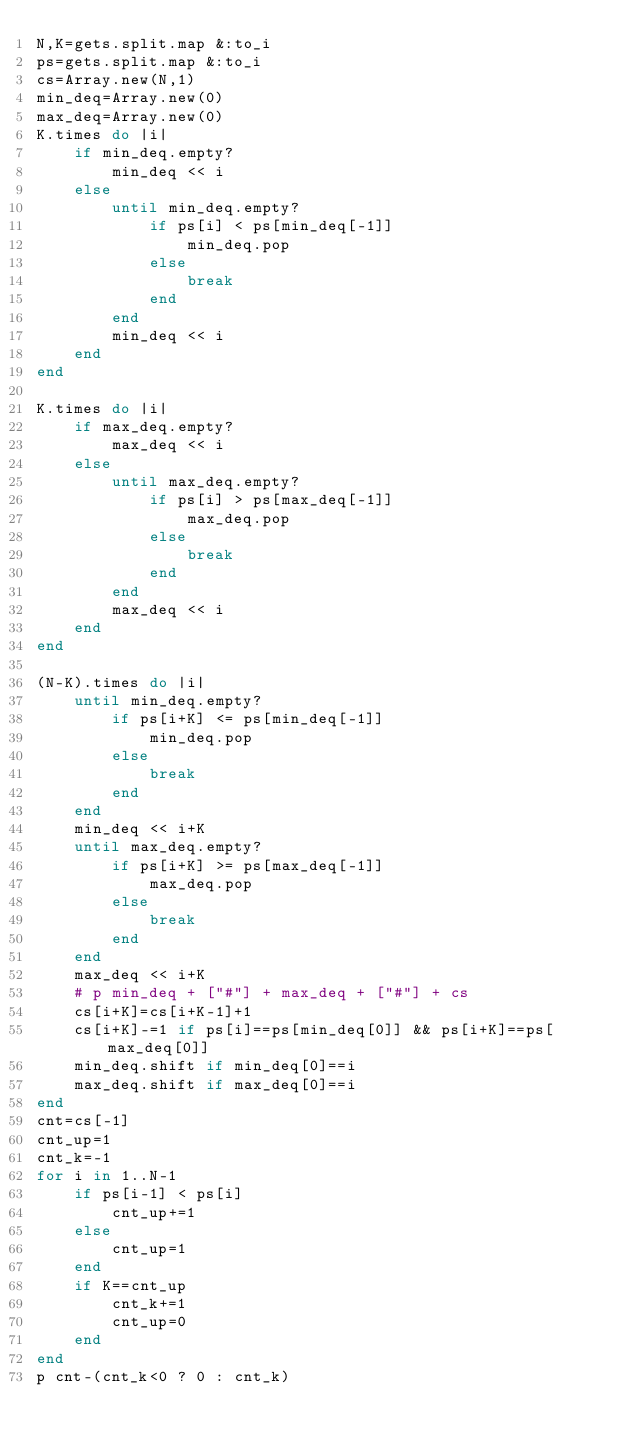Convert code to text. <code><loc_0><loc_0><loc_500><loc_500><_Ruby_>N,K=gets.split.map &:to_i
ps=gets.split.map &:to_i
cs=Array.new(N,1)
min_deq=Array.new(0)
max_deq=Array.new(0)
K.times do |i|
    if min_deq.empty?
        min_deq << i
    else
        until min_deq.empty?
            if ps[i] < ps[min_deq[-1]]
                min_deq.pop
            else
                break
            end
        end
        min_deq << i
    end
end

K.times do |i|
    if max_deq.empty?
        max_deq << i
    else
        until max_deq.empty?
            if ps[i] > ps[max_deq[-1]]
                max_deq.pop
            else
                break
            end
        end
        max_deq << i
    end
end

(N-K).times do |i|
    until min_deq.empty?
        if ps[i+K] <= ps[min_deq[-1]]
            min_deq.pop
        else
            break
        end
    end
    min_deq << i+K
    until max_deq.empty?
        if ps[i+K] >= ps[max_deq[-1]]
            max_deq.pop
        else
            break
        end
    end
    max_deq << i+K
    # p min_deq + ["#"] + max_deq + ["#"] + cs
    cs[i+K]=cs[i+K-1]+1
    cs[i+K]-=1 if ps[i]==ps[min_deq[0]] && ps[i+K]==ps[max_deq[0]]
    min_deq.shift if min_deq[0]==i
    max_deq.shift if max_deq[0]==i
end
cnt=cs[-1]
cnt_up=1
cnt_k=-1
for i in 1..N-1
    if ps[i-1] < ps[i]
        cnt_up+=1
    else
        cnt_up=1
    end
    if K==cnt_up
        cnt_k+=1
        cnt_up=0
    end
end
p cnt-(cnt_k<0 ? 0 : cnt_k)
</code> 